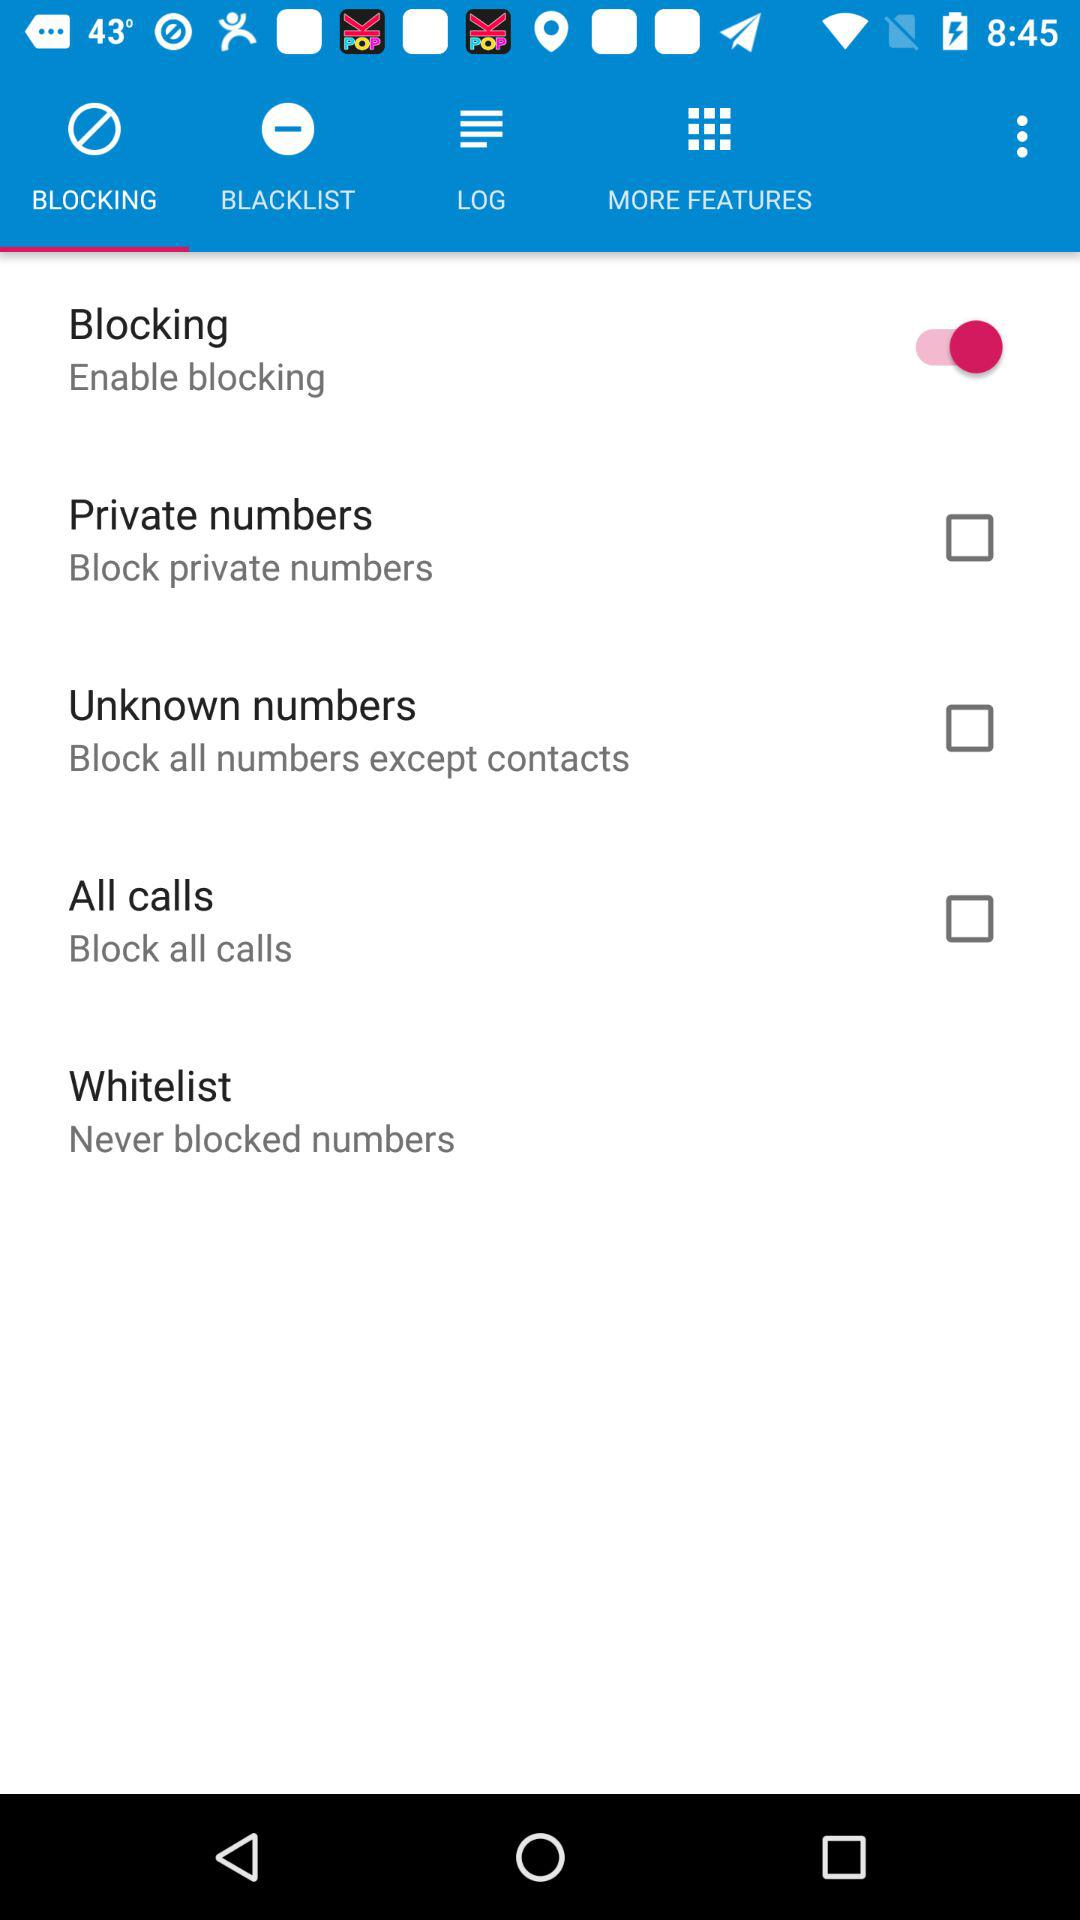What's the status of "Blocking"? The status of "Blocking" is "on". 